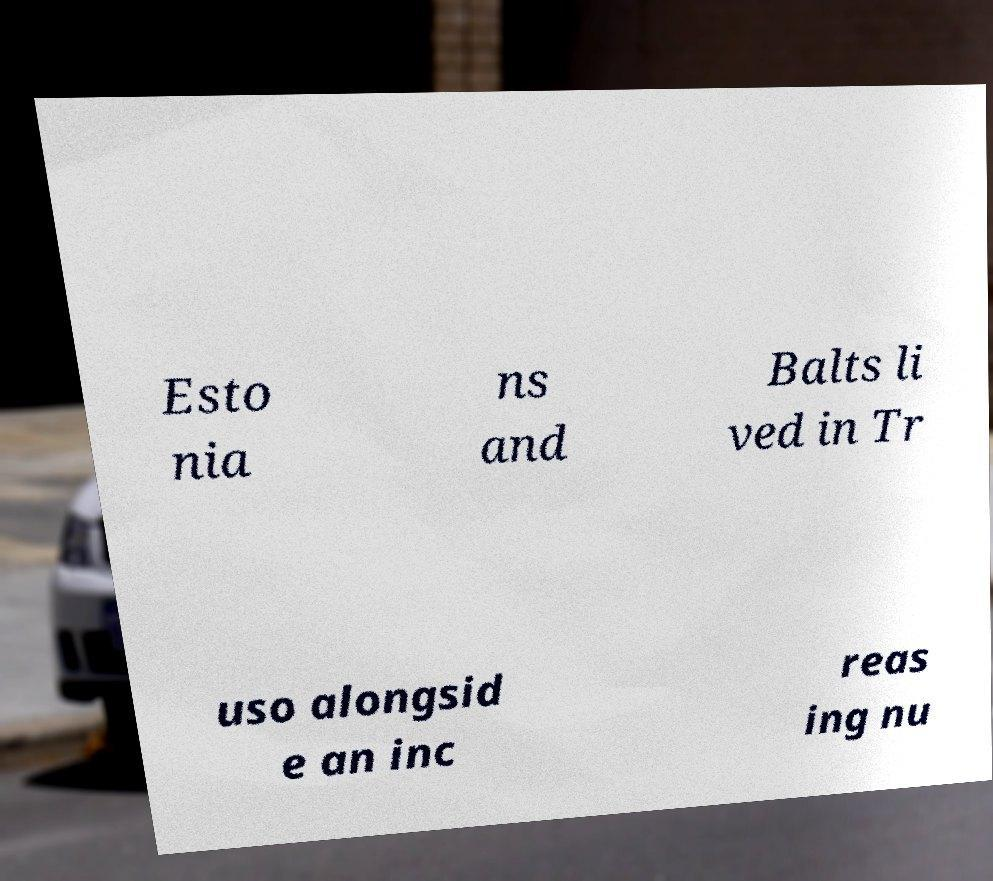What messages or text are displayed in this image? I need them in a readable, typed format. Esto nia ns and Balts li ved in Tr uso alongsid e an inc reas ing nu 